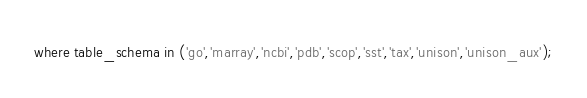<code> <loc_0><loc_0><loc_500><loc_500><_SQL_>where table_schema in ('go','marray','ncbi','pdb','scop','sst','tax','unison','unison_aux');
</code> 